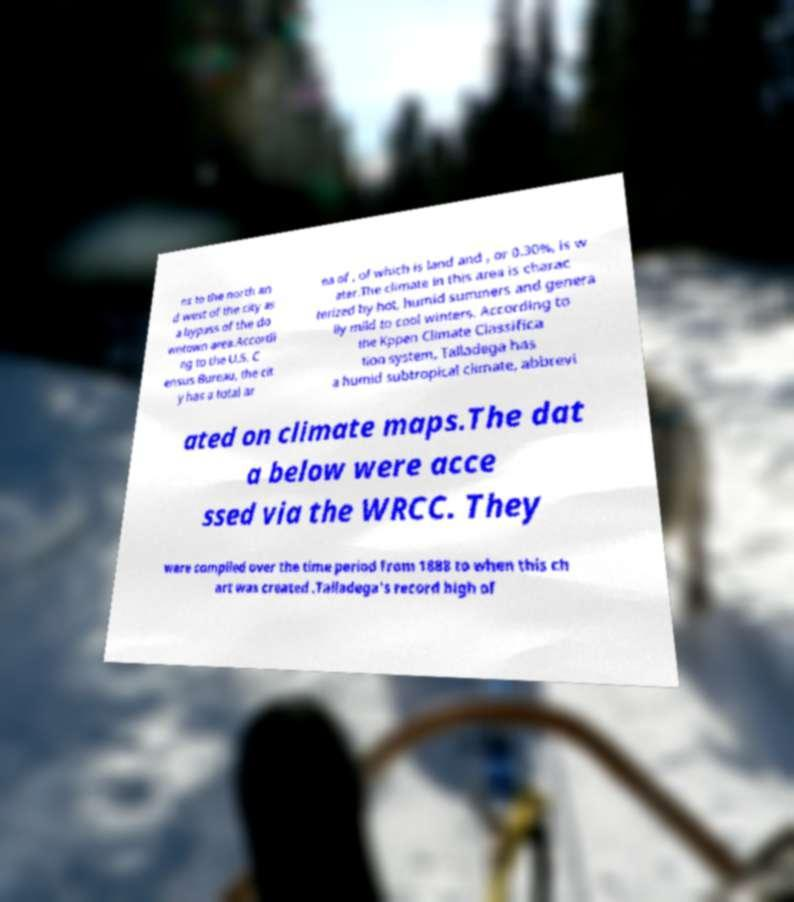I need the written content from this picture converted into text. Can you do that? ns to the north an d west of the city as a bypass of the do wntown area.Accordi ng to the U.S. C ensus Bureau, the cit y has a total ar ea of , of which is land and , or 0.30%, is w ater.The climate in this area is charac terized by hot, humid summers and genera lly mild to cool winters. According to the Kppen Climate Classifica tion system, Talladega has a humid subtropical climate, abbrevi ated on climate maps.The dat a below were acce ssed via the WRCC. They were compiled over the time period from 1888 to when this ch art was created .Talladega's record high of 